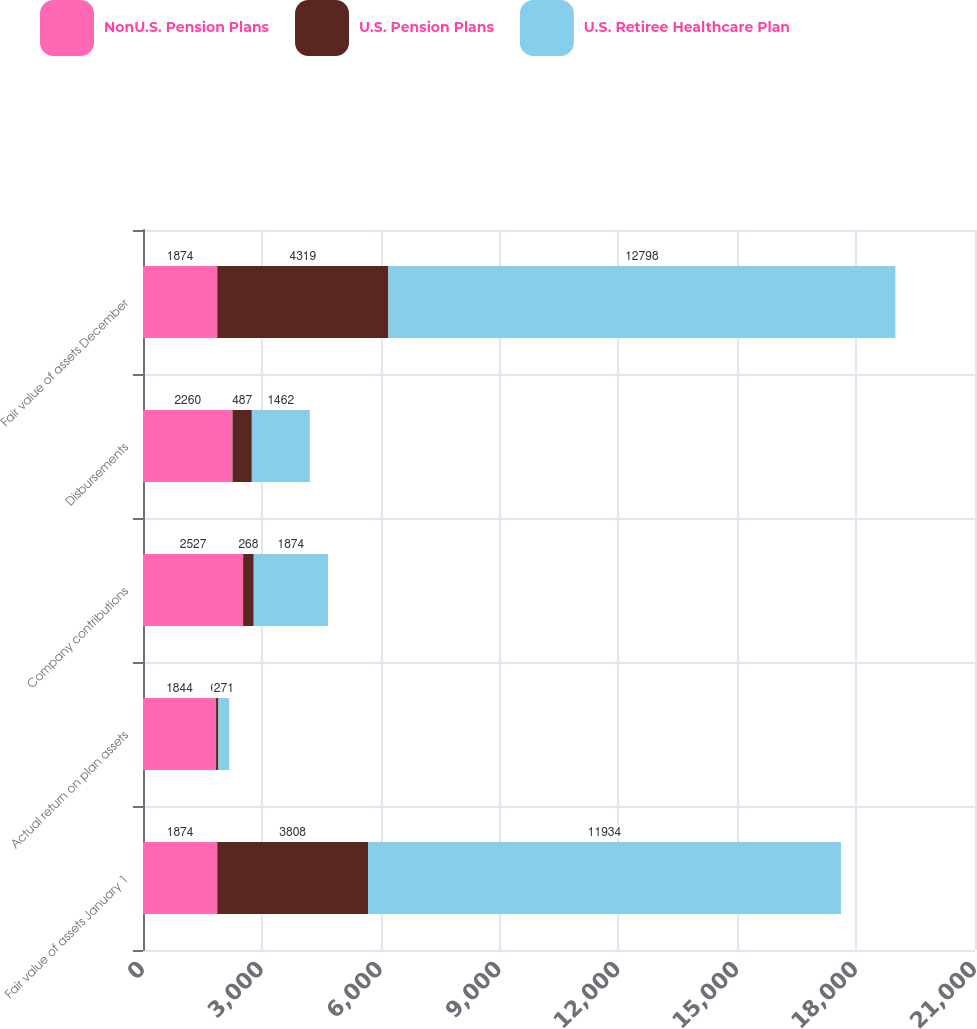Convert chart. <chart><loc_0><loc_0><loc_500><loc_500><stacked_bar_chart><ecel><fcel>Fair value of assets January 1<fcel>Actual return on plan assets<fcel>Company contributions<fcel>Disbursements<fcel>Fair value of assets December<nl><fcel>NonU.S. Pension Plans<fcel>1874<fcel>1844<fcel>2527<fcel>2260<fcel>1874<nl><fcel>U.S. Pension Plans<fcel>3808<fcel>61<fcel>268<fcel>487<fcel>4319<nl><fcel>U.S. Retiree Healthcare Plan<fcel>11934<fcel>271<fcel>1874<fcel>1462<fcel>12798<nl></chart> 